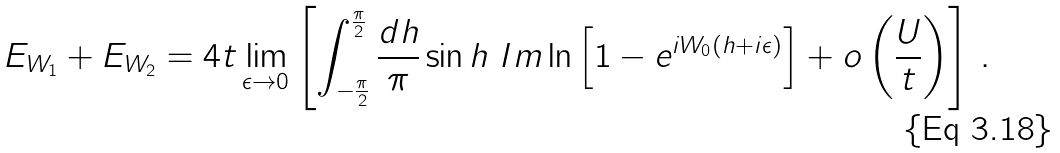Convert formula to latex. <formula><loc_0><loc_0><loc_500><loc_500>E _ { W _ { 1 } } + E _ { W _ { 2 } } = 4 t \lim _ { \epsilon \rightarrow 0 } \left [ \int _ { - \frac { \pi } { 2 } } ^ { \frac { \pi } { 2 } } \frac { d h } { \pi } \sin h \ { I m } \ln \left [ 1 - e ^ { i W _ { 0 } ( h + i \epsilon ) } \right ] + o \left ( \frac { U } { t } \right ) \right ] \, .</formula> 